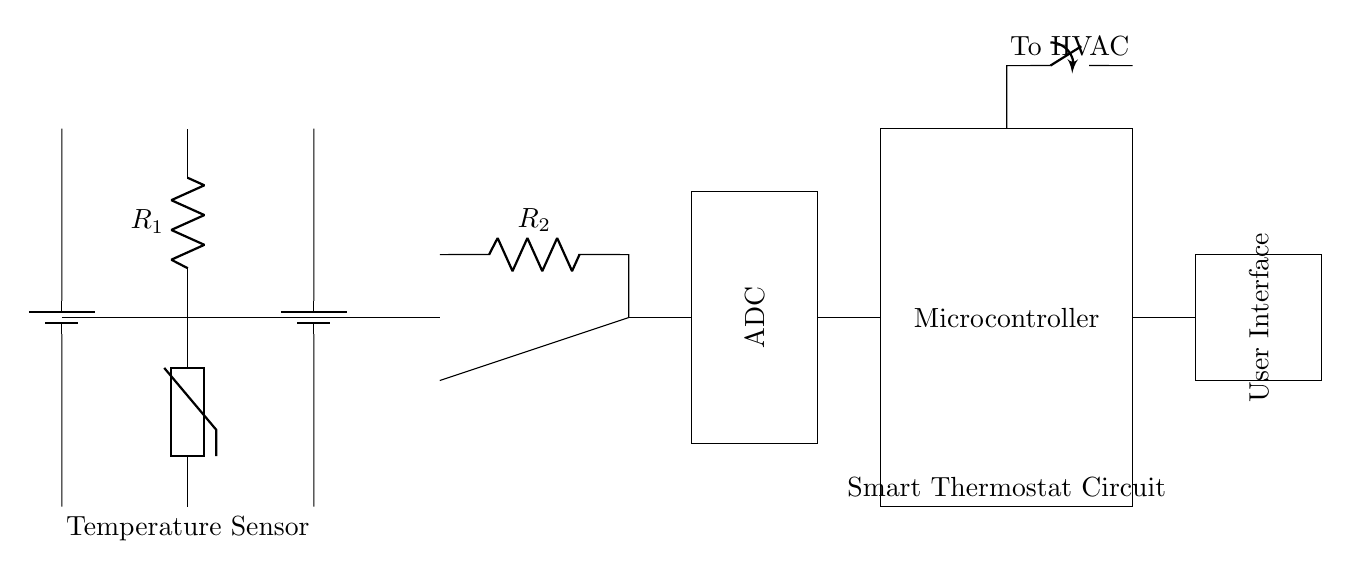What is the main function of the thermistor in this circuit? The thermistor acts as a temperature sensor, changing its resistance based on the ambient temperature. It allows the circuit to monitor temperature for efficient climate control.
Answer: Temperature sensor What component converts the analog signal to a digital signal? The ADC (Analog to Digital Converter) takes the analog signal from the thermistor and converts it into a digital signal that the microcontroller can process.
Answer: ADC How many resistors are present in the circuit? There are two resistors labeled R1 and R2 in the circuit diagram. They are used in conjunction with the thermistor and operational amplifier.
Answer: Two What is the role of the microcontroller in this circuit? The microcontroller processes the digital signals from the ADC, allowing programmable control over the HVAC system based on the temperature data received.
Answer: Programmable control What does the closing switch control in this circuit? The closing switch connects to the HVAC system, allowing the microcontroller to turn the heating or cooling system on or off based on temperature readings.
Answer: HVAC control Which component provides power to the circuit? The battery serves as the power supply for the complete circuit, providing the necessary voltage for all components to function.
Answer: Battery What is the purpose of the user interface in this circuit? The user interface allows users to program and interact with the smart thermostat settings and preferences. It provides a means for the user to configure temperature settings.
Answer: User configuration 